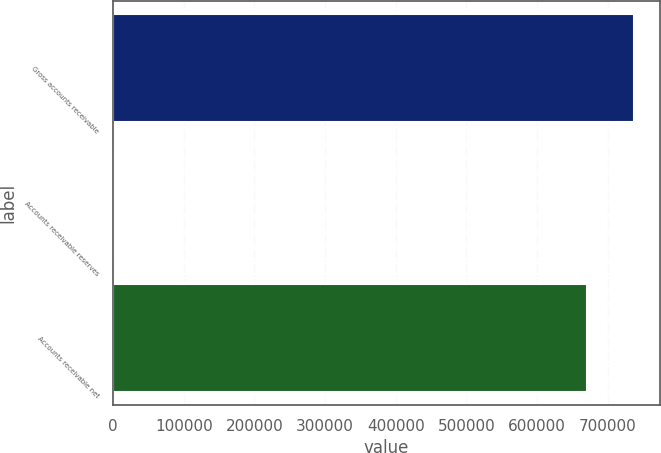Convert chart to OTSL. <chart><loc_0><loc_0><loc_500><loc_500><bar_chart><fcel>Gross accounts receivable<fcel>Accounts receivable reserves<fcel>Accounts receivable net<nl><fcel>737442<fcel>1069<fcel>670402<nl></chart> 